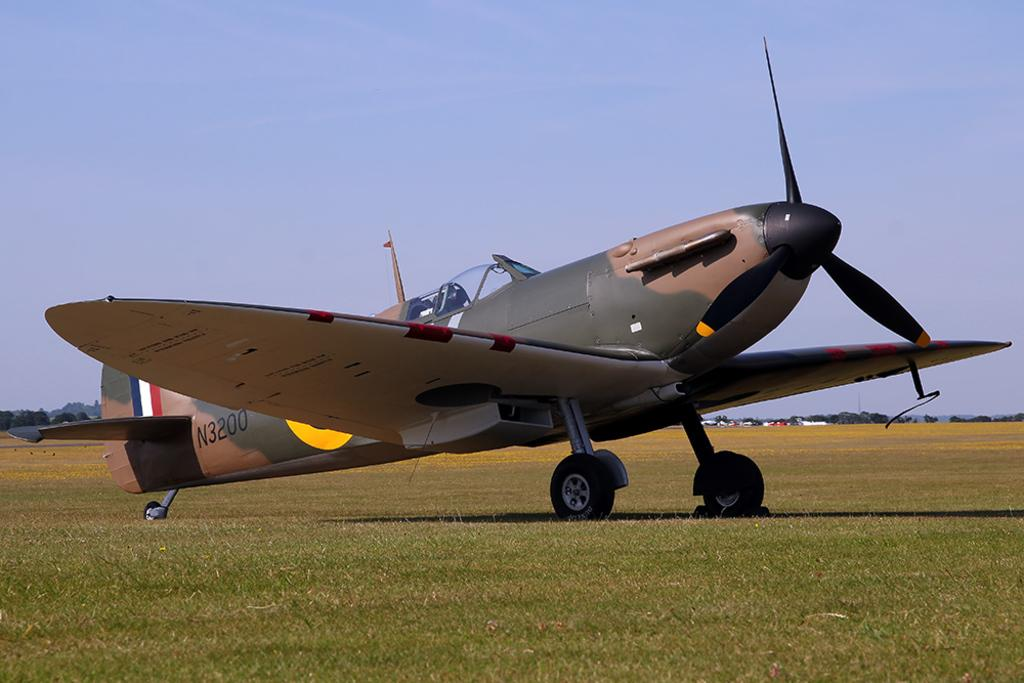What is the main subject of the image? The main subject of the image is an aircraft with a number on the ground. What is the ground surface like? The ground has grass on it. What can be seen in the background of the image? There are trees and the sky visible in the background of the image. What type of soap is being used to clean the aircraft's windows in the image? There is no soap or cleaning activity depicted in the image; it only shows an aircraft with a number on the ground. Can you tell me how many ears are visible on the aircraft in the image? Aircrafts do not have ears, so there are no ears visible in the image. 